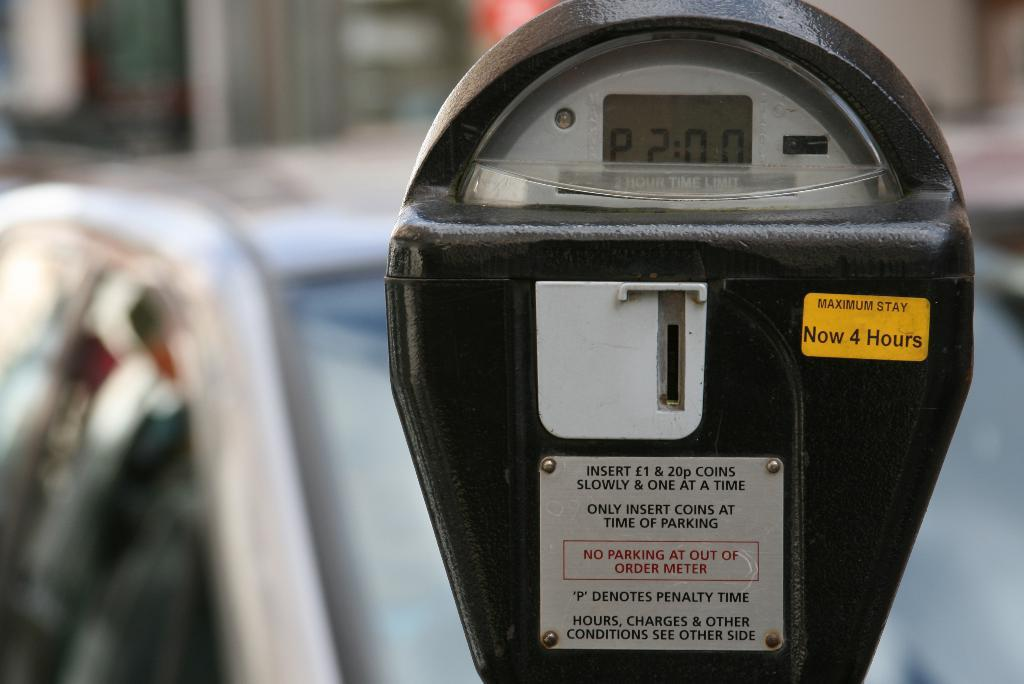<image>
Write a terse but informative summary of the picture. A parking meter with the time 2:00 on the clock and maximum stay is 4 hours. 